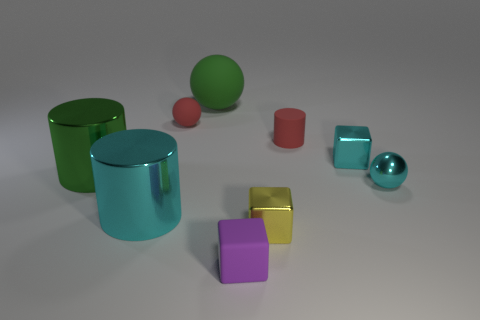Add 1 big cyan objects. How many objects exist? 10 Subtract all cylinders. How many objects are left? 6 Add 8 tiny red balls. How many tiny red balls are left? 9 Add 8 cyan cylinders. How many cyan cylinders exist? 9 Subtract 1 red balls. How many objects are left? 8 Subtract all tiny brown blocks. Subtract all tiny cyan metallic balls. How many objects are left? 8 